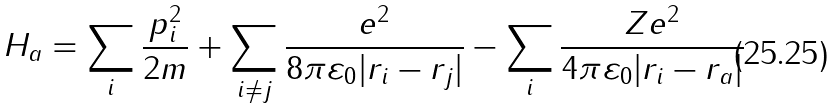<formula> <loc_0><loc_0><loc_500><loc_500>H _ { a } = \sum _ { i } \frac { p _ { i } ^ { 2 } } { 2 m } + \sum _ { i \neq j } \frac { e ^ { 2 } } { 8 \pi \varepsilon _ { 0 } | { { r } _ { i } - { r } _ { j } } | } - \sum _ { i } \frac { Z e ^ { 2 } } { 4 \pi \varepsilon _ { 0 } | { r } _ { i } - { r } _ { a } | }</formula> 